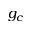Convert formula to latex. <formula><loc_0><loc_0><loc_500><loc_500>g _ { c }</formula> 